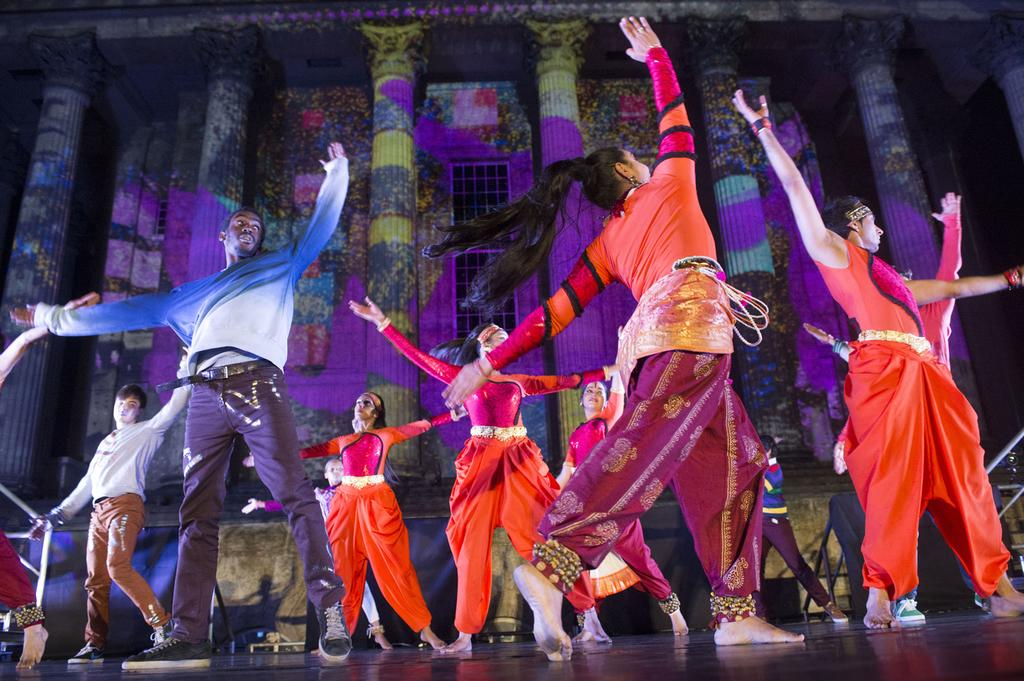What are the persons in the image doing? The persons in the image are dancing. Where is the dancing taking place? The dancing is taking place on the floor. What can be seen in the background of the image? There is a building, windows, and pillars visible in the background of the image. What type of balloon is floating above the dancers in the image? There is no balloon present in the image; the focus is on the persons dancing and the background elements. 